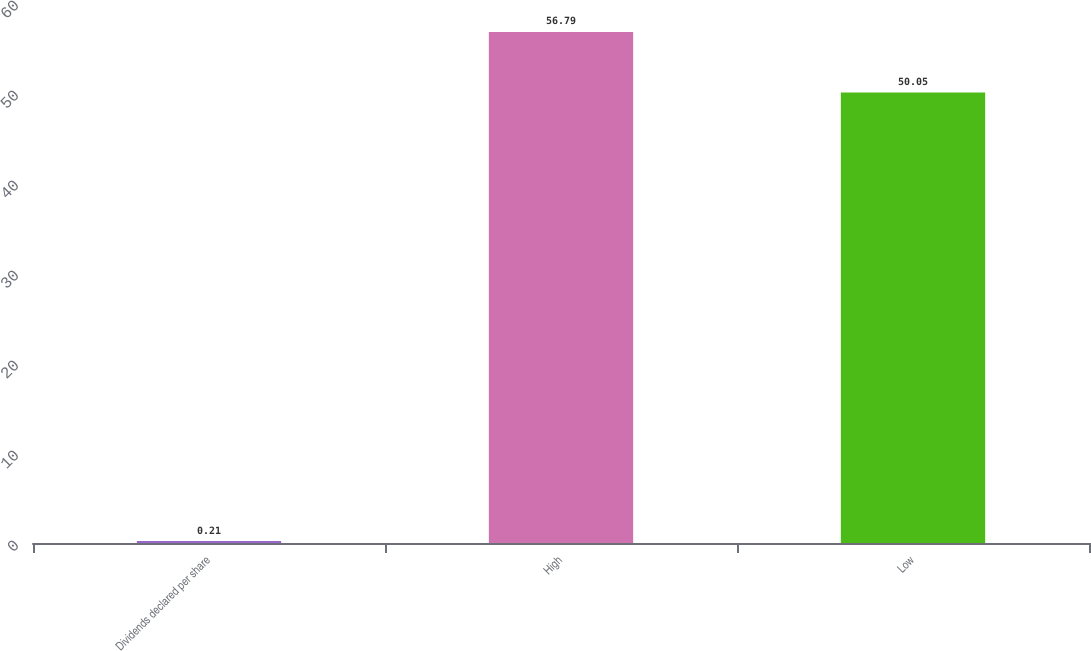Convert chart. <chart><loc_0><loc_0><loc_500><loc_500><bar_chart><fcel>Dividends declared per share<fcel>High<fcel>Low<nl><fcel>0.21<fcel>56.79<fcel>50.05<nl></chart> 